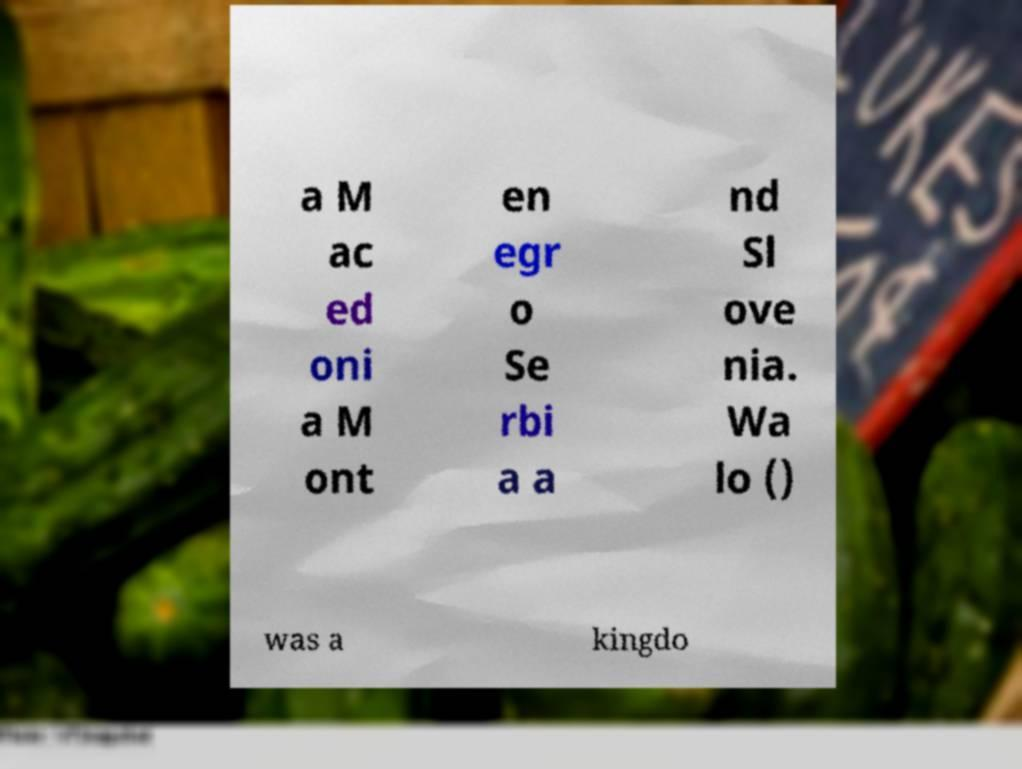Can you accurately transcribe the text from the provided image for me? a M ac ed oni a M ont en egr o Se rbi a a nd Sl ove nia. Wa lo () was a kingdo 